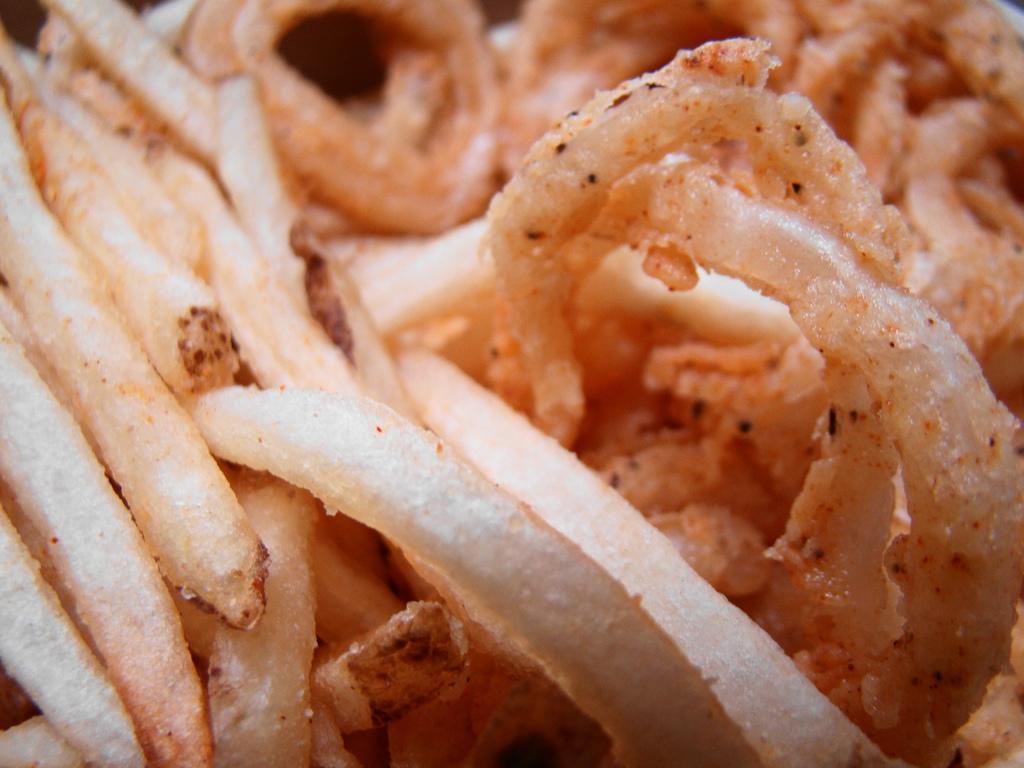Describe this image in one or two sentences. In this image we can see a food item. 